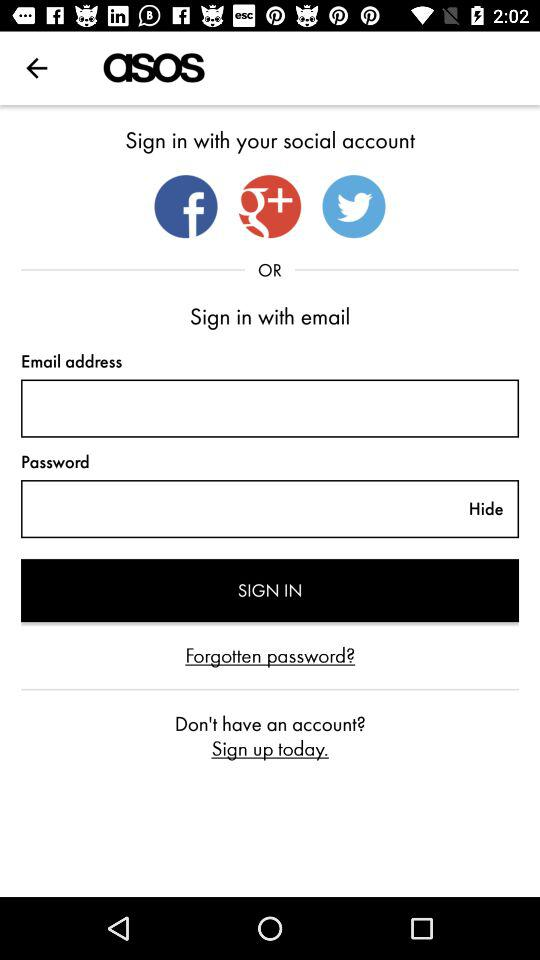How many social media options are there to sign in with?
Answer the question using a single word or phrase. 3 